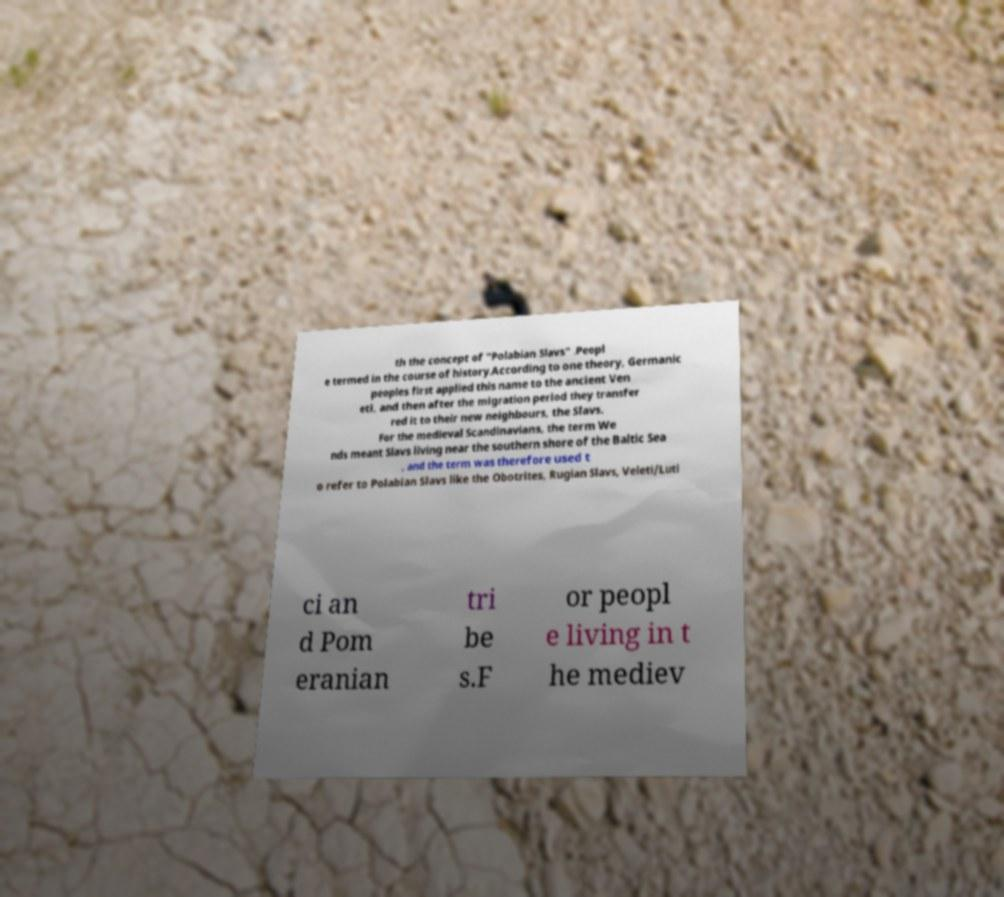Could you assist in decoding the text presented in this image and type it out clearly? th the concept of "Polabian Slavs" .Peopl e termed in the course of history.According to one theory, Germanic peoples first applied this name to the ancient Ven eti, and then after the migration period they transfer red it to their new neighbours, the Slavs. For the medieval Scandinavians, the term We nds meant Slavs living near the southern shore of the Baltic Sea , and the term was therefore used t o refer to Polabian Slavs like the Obotrites, Rugian Slavs, Veleti/Luti ci an d Pom eranian tri be s.F or peopl e living in t he mediev 